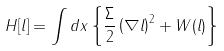Convert formula to latex. <formula><loc_0><loc_0><loc_500><loc_500>H [ l ] = \int d { x } \left \{ \frac { \Sigma } { 2 } \left ( \nabla l \right ) ^ { 2 } + W ( l ) \right \}</formula> 